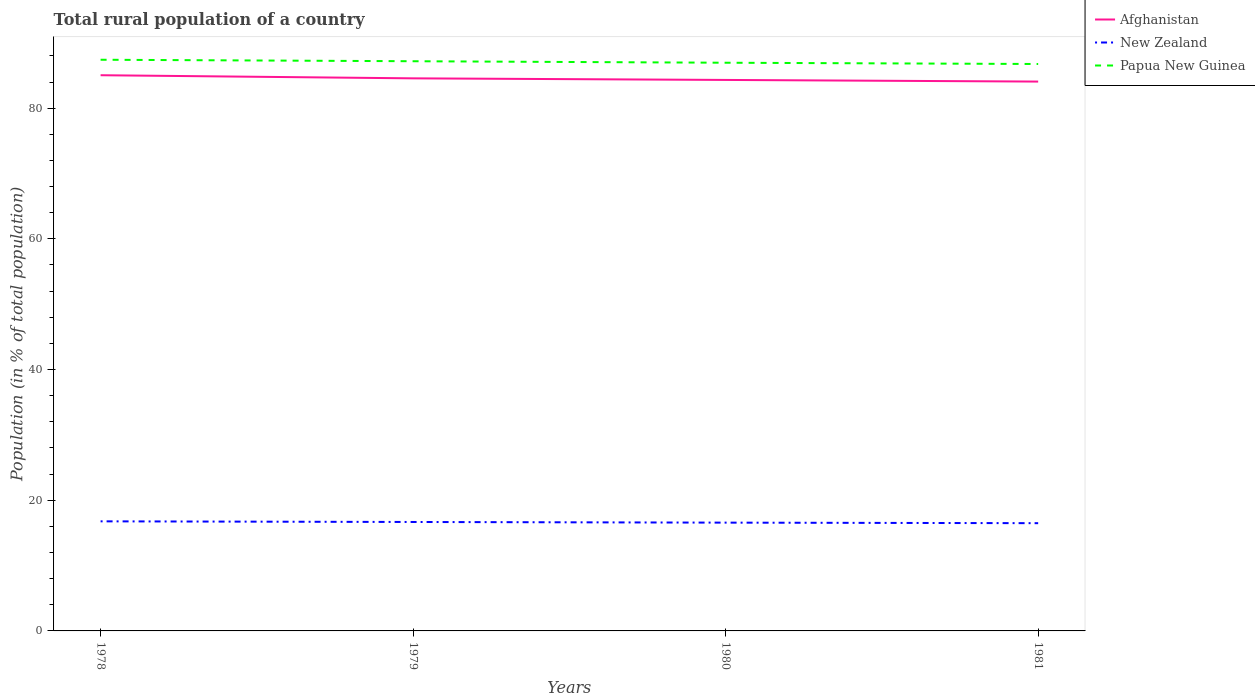Is the number of lines equal to the number of legend labels?
Provide a succinct answer. Yes. Across all years, what is the maximum rural population in Papua New Guinea?
Give a very brief answer. 86.76. In which year was the rural population in Papua New Guinea maximum?
Ensure brevity in your answer.  1981. What is the total rural population in Afghanistan in the graph?
Offer a terse response. 0.25. What is the difference between the highest and the second highest rural population in Afghanistan?
Provide a short and direct response. 0.97. Are the values on the major ticks of Y-axis written in scientific E-notation?
Make the answer very short. No. Does the graph contain grids?
Your response must be concise. No. What is the title of the graph?
Offer a very short reply. Total rural population of a country. Does "Israel" appear as one of the legend labels in the graph?
Provide a succinct answer. No. What is the label or title of the Y-axis?
Your response must be concise. Population (in % of total population). What is the Population (in % of total population) in Afghanistan in 1978?
Offer a very short reply. 85.04. What is the Population (in % of total population) of New Zealand in 1978?
Your answer should be very brief. 16.77. What is the Population (in % of total population) in Papua New Guinea in 1978?
Your answer should be compact. 87.41. What is the Population (in % of total population) in Afghanistan in 1979?
Make the answer very short. 84.56. What is the Population (in % of total population) in New Zealand in 1979?
Provide a succinct answer. 16.67. What is the Population (in % of total population) of Papua New Guinea in 1979?
Your answer should be very brief. 87.18. What is the Population (in % of total population) of Afghanistan in 1980?
Your response must be concise. 84.32. What is the Population (in % of total population) of New Zealand in 1980?
Offer a terse response. 16.57. What is the Population (in % of total population) in Papua New Guinea in 1980?
Make the answer very short. 86.95. What is the Population (in % of total population) in Afghanistan in 1981?
Give a very brief answer. 84.07. What is the Population (in % of total population) of New Zealand in 1981?
Offer a terse response. 16.49. What is the Population (in % of total population) of Papua New Guinea in 1981?
Keep it short and to the point. 86.76. Across all years, what is the maximum Population (in % of total population) of Afghanistan?
Your answer should be very brief. 85.04. Across all years, what is the maximum Population (in % of total population) of New Zealand?
Provide a succinct answer. 16.77. Across all years, what is the maximum Population (in % of total population) of Papua New Guinea?
Give a very brief answer. 87.41. Across all years, what is the minimum Population (in % of total population) of Afghanistan?
Provide a short and direct response. 84.07. Across all years, what is the minimum Population (in % of total population) in New Zealand?
Give a very brief answer. 16.49. Across all years, what is the minimum Population (in % of total population) of Papua New Guinea?
Keep it short and to the point. 86.76. What is the total Population (in % of total population) of Afghanistan in the graph?
Provide a succinct answer. 338. What is the total Population (in % of total population) in New Zealand in the graph?
Your answer should be very brief. 66.5. What is the total Population (in % of total population) of Papua New Guinea in the graph?
Ensure brevity in your answer.  348.3. What is the difference between the Population (in % of total population) of Afghanistan in 1978 and that in 1979?
Your answer should be compact. 0.48. What is the difference between the Population (in % of total population) in New Zealand in 1978 and that in 1979?
Keep it short and to the point. 0.1. What is the difference between the Population (in % of total population) in Papua New Guinea in 1978 and that in 1979?
Offer a terse response. 0.23. What is the difference between the Population (in % of total population) in Afghanistan in 1978 and that in 1980?
Your response must be concise. 0.72. What is the difference between the Population (in % of total population) in New Zealand in 1978 and that in 1980?
Offer a terse response. 0.2. What is the difference between the Population (in % of total population) of Papua New Guinea in 1978 and that in 1980?
Make the answer very short. 0.46. What is the difference between the Population (in % of total population) in New Zealand in 1978 and that in 1981?
Your response must be concise. 0.28. What is the difference between the Population (in % of total population) of Papua New Guinea in 1978 and that in 1981?
Provide a short and direct response. 0.65. What is the difference between the Population (in % of total population) in Afghanistan in 1979 and that in 1980?
Make the answer very short. 0.25. What is the difference between the Population (in % of total population) of Papua New Guinea in 1979 and that in 1980?
Offer a terse response. 0.23. What is the difference between the Population (in % of total population) in Afghanistan in 1979 and that in 1981?
Your response must be concise. 0.49. What is the difference between the Population (in % of total population) in New Zealand in 1979 and that in 1981?
Your answer should be compact. 0.18. What is the difference between the Population (in % of total population) in Papua New Guinea in 1979 and that in 1981?
Keep it short and to the point. 0.42. What is the difference between the Population (in % of total population) in Afghanistan in 1980 and that in 1981?
Offer a terse response. 0.25. What is the difference between the Population (in % of total population) of New Zealand in 1980 and that in 1981?
Offer a terse response. 0.08. What is the difference between the Population (in % of total population) in Papua New Guinea in 1980 and that in 1981?
Give a very brief answer. 0.2. What is the difference between the Population (in % of total population) in Afghanistan in 1978 and the Population (in % of total population) in New Zealand in 1979?
Offer a terse response. 68.37. What is the difference between the Population (in % of total population) of Afghanistan in 1978 and the Population (in % of total population) of Papua New Guinea in 1979?
Your answer should be very brief. -2.14. What is the difference between the Population (in % of total population) of New Zealand in 1978 and the Population (in % of total population) of Papua New Guinea in 1979?
Provide a short and direct response. -70.41. What is the difference between the Population (in % of total population) in Afghanistan in 1978 and the Population (in % of total population) in New Zealand in 1980?
Give a very brief answer. 68.47. What is the difference between the Population (in % of total population) in Afghanistan in 1978 and the Population (in % of total population) in Papua New Guinea in 1980?
Offer a terse response. -1.91. What is the difference between the Population (in % of total population) in New Zealand in 1978 and the Population (in % of total population) in Papua New Guinea in 1980?
Provide a short and direct response. -70.18. What is the difference between the Population (in % of total population) of Afghanistan in 1978 and the Population (in % of total population) of New Zealand in 1981?
Provide a succinct answer. 68.55. What is the difference between the Population (in % of total population) of Afghanistan in 1978 and the Population (in % of total population) of Papua New Guinea in 1981?
Keep it short and to the point. -1.72. What is the difference between the Population (in % of total population) of New Zealand in 1978 and the Population (in % of total population) of Papua New Guinea in 1981?
Give a very brief answer. -69.99. What is the difference between the Population (in % of total population) in Afghanistan in 1979 and the Population (in % of total population) in New Zealand in 1980?
Make the answer very short. 67.99. What is the difference between the Population (in % of total population) in Afghanistan in 1979 and the Population (in % of total population) in Papua New Guinea in 1980?
Keep it short and to the point. -2.39. What is the difference between the Population (in % of total population) in New Zealand in 1979 and the Population (in % of total population) in Papua New Guinea in 1980?
Make the answer very short. -70.28. What is the difference between the Population (in % of total population) in Afghanistan in 1979 and the Population (in % of total population) in New Zealand in 1981?
Offer a terse response. 68.08. What is the difference between the Population (in % of total population) in Afghanistan in 1979 and the Population (in % of total population) in Papua New Guinea in 1981?
Give a very brief answer. -2.19. What is the difference between the Population (in % of total population) of New Zealand in 1979 and the Population (in % of total population) of Papua New Guinea in 1981?
Your answer should be compact. -70.09. What is the difference between the Population (in % of total population) in Afghanistan in 1980 and the Population (in % of total population) in New Zealand in 1981?
Keep it short and to the point. 67.83. What is the difference between the Population (in % of total population) in Afghanistan in 1980 and the Population (in % of total population) in Papua New Guinea in 1981?
Make the answer very short. -2.44. What is the difference between the Population (in % of total population) of New Zealand in 1980 and the Population (in % of total population) of Papua New Guinea in 1981?
Provide a succinct answer. -70.19. What is the average Population (in % of total population) of Afghanistan per year?
Offer a very short reply. 84.5. What is the average Population (in % of total population) in New Zealand per year?
Keep it short and to the point. 16.63. What is the average Population (in % of total population) of Papua New Guinea per year?
Give a very brief answer. 87.08. In the year 1978, what is the difference between the Population (in % of total population) in Afghanistan and Population (in % of total population) in New Zealand?
Give a very brief answer. 68.27. In the year 1978, what is the difference between the Population (in % of total population) of Afghanistan and Population (in % of total population) of Papua New Guinea?
Ensure brevity in your answer.  -2.37. In the year 1978, what is the difference between the Population (in % of total population) in New Zealand and Population (in % of total population) in Papua New Guinea?
Give a very brief answer. -70.64. In the year 1979, what is the difference between the Population (in % of total population) of Afghanistan and Population (in % of total population) of New Zealand?
Your response must be concise. 67.89. In the year 1979, what is the difference between the Population (in % of total population) in Afghanistan and Population (in % of total population) in Papua New Guinea?
Your answer should be very brief. -2.62. In the year 1979, what is the difference between the Population (in % of total population) of New Zealand and Population (in % of total population) of Papua New Guinea?
Offer a terse response. -70.51. In the year 1980, what is the difference between the Population (in % of total population) in Afghanistan and Population (in % of total population) in New Zealand?
Your response must be concise. 67.75. In the year 1980, what is the difference between the Population (in % of total population) of Afghanistan and Population (in % of total population) of Papua New Guinea?
Your answer should be compact. -2.63. In the year 1980, what is the difference between the Population (in % of total population) of New Zealand and Population (in % of total population) of Papua New Guinea?
Provide a short and direct response. -70.38. In the year 1981, what is the difference between the Population (in % of total population) in Afghanistan and Population (in % of total population) in New Zealand?
Your response must be concise. 67.58. In the year 1981, what is the difference between the Population (in % of total population) of Afghanistan and Population (in % of total population) of Papua New Guinea?
Your answer should be very brief. -2.69. In the year 1981, what is the difference between the Population (in % of total population) of New Zealand and Population (in % of total population) of Papua New Guinea?
Make the answer very short. -70.27. What is the ratio of the Population (in % of total population) of Afghanistan in 1978 to that in 1979?
Offer a very short reply. 1.01. What is the ratio of the Population (in % of total population) of New Zealand in 1978 to that in 1979?
Make the answer very short. 1.01. What is the ratio of the Population (in % of total population) of Afghanistan in 1978 to that in 1980?
Keep it short and to the point. 1.01. What is the ratio of the Population (in % of total population) in Afghanistan in 1978 to that in 1981?
Keep it short and to the point. 1.01. What is the ratio of the Population (in % of total population) of New Zealand in 1978 to that in 1981?
Make the answer very short. 1.02. What is the ratio of the Population (in % of total population) in Papua New Guinea in 1978 to that in 1981?
Offer a terse response. 1.01. What is the ratio of the Population (in % of total population) of Afghanistan in 1979 to that in 1980?
Your answer should be compact. 1. What is the ratio of the Population (in % of total population) in Afghanistan in 1979 to that in 1981?
Your answer should be compact. 1.01. What is the ratio of the Population (in % of total population) of New Zealand in 1979 to that in 1981?
Offer a very short reply. 1.01. What is the ratio of the Population (in % of total population) of New Zealand in 1980 to that in 1981?
Make the answer very short. 1. What is the ratio of the Population (in % of total population) in Papua New Guinea in 1980 to that in 1981?
Keep it short and to the point. 1. What is the difference between the highest and the second highest Population (in % of total population) of Afghanistan?
Ensure brevity in your answer.  0.48. What is the difference between the highest and the second highest Population (in % of total population) of New Zealand?
Your response must be concise. 0.1. What is the difference between the highest and the second highest Population (in % of total population) in Papua New Guinea?
Keep it short and to the point. 0.23. What is the difference between the highest and the lowest Population (in % of total population) in New Zealand?
Give a very brief answer. 0.28. What is the difference between the highest and the lowest Population (in % of total population) of Papua New Guinea?
Your response must be concise. 0.65. 